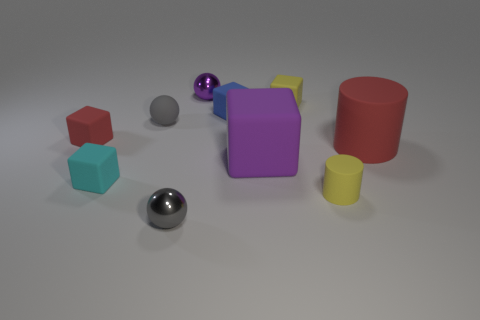Subtract all green cubes. Subtract all blue cylinders. How many cubes are left? 5 Subtract all spheres. How many objects are left? 7 Subtract 0 purple cylinders. How many objects are left? 10 Subtract all big purple objects. Subtract all small gray objects. How many objects are left? 7 Add 7 tiny cylinders. How many tiny cylinders are left? 8 Add 3 cyan rubber objects. How many cyan rubber objects exist? 4 